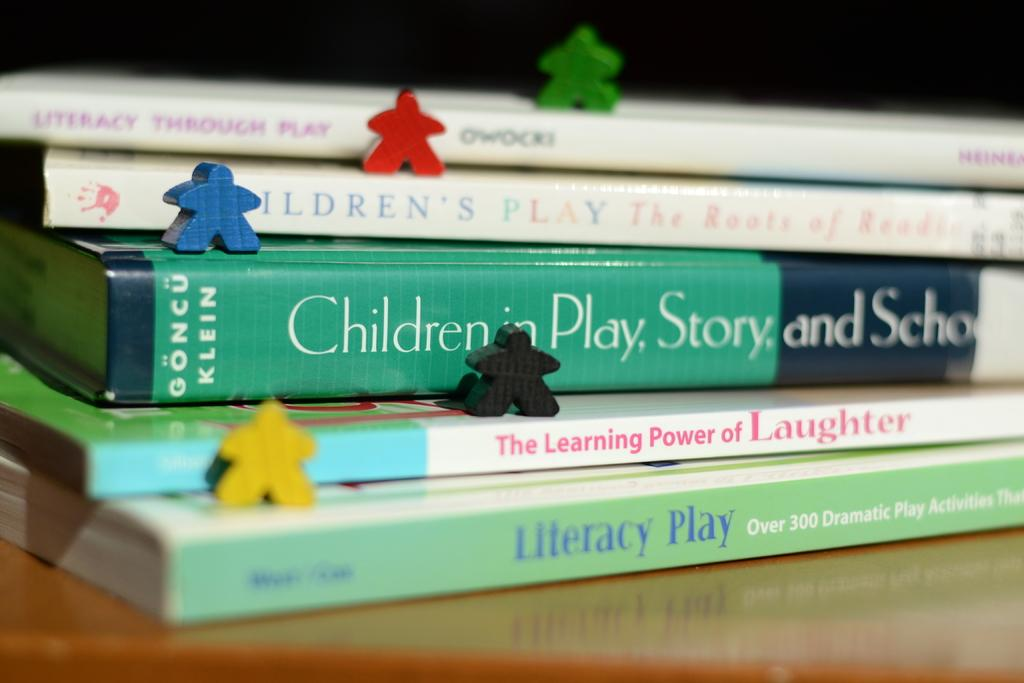<image>
Relay a brief, clear account of the picture shown. A book titled Children in play,story, and school is in a stack of books. 